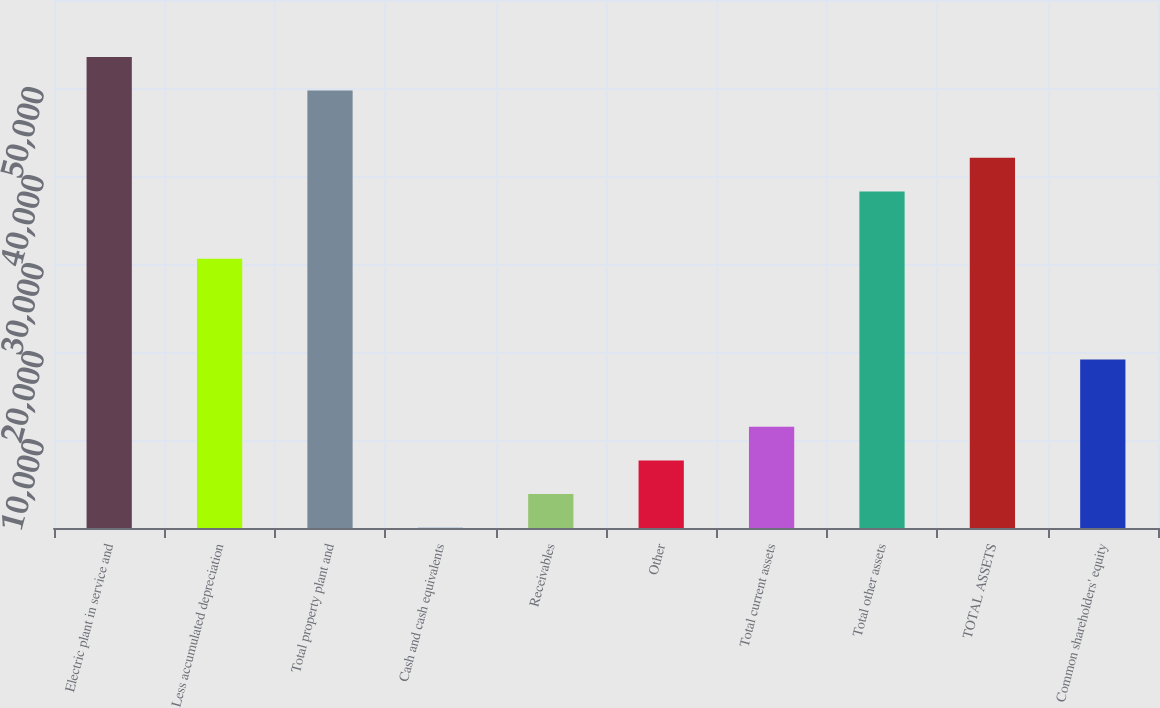Convert chart. <chart><loc_0><loc_0><loc_500><loc_500><bar_chart><fcel>Electric plant in service and<fcel>Less accumulated depreciation<fcel>Total property plant and<fcel>Cash and cash equivalents<fcel>Receivables<fcel>Other<fcel>Total current assets<fcel>Total other assets<fcel>TOTAL ASSETS<fcel>Common shareholders' equity<nl><fcel>53531.2<fcel>30606.4<fcel>49710.4<fcel>40<fcel>3860.8<fcel>7681.6<fcel>11502.4<fcel>38248<fcel>42068.8<fcel>19144<nl></chart> 